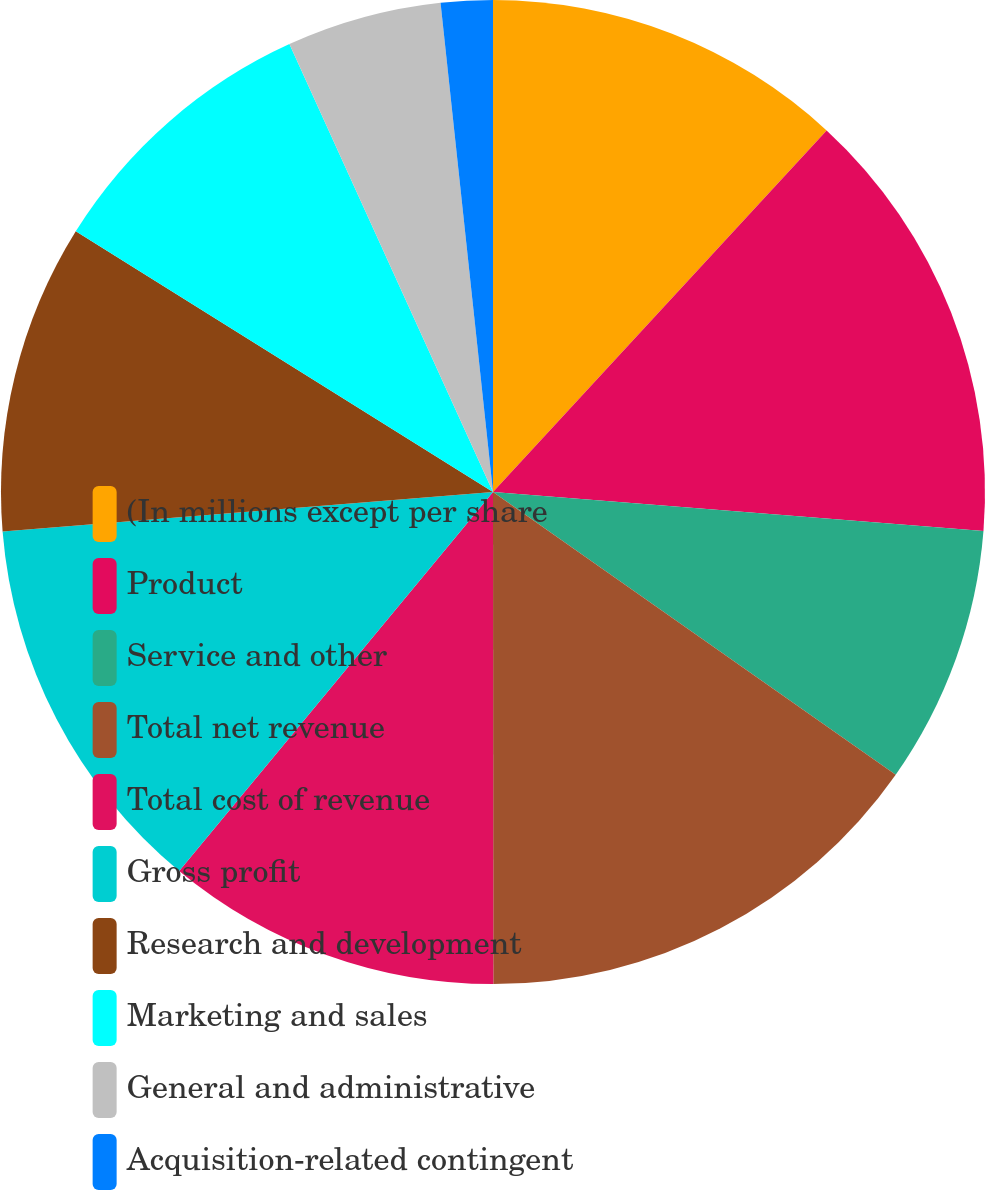Convert chart. <chart><loc_0><loc_0><loc_500><loc_500><pie_chart><fcel>(In millions except per share<fcel>Product<fcel>Service and other<fcel>Total net revenue<fcel>Total cost of revenue<fcel>Gross profit<fcel>Research and development<fcel>Marketing and sales<fcel>General and administrative<fcel>Acquisition-related contingent<nl><fcel>11.86%<fcel>14.4%<fcel>8.48%<fcel>15.25%<fcel>11.02%<fcel>12.71%<fcel>10.17%<fcel>9.32%<fcel>5.09%<fcel>1.7%<nl></chart> 